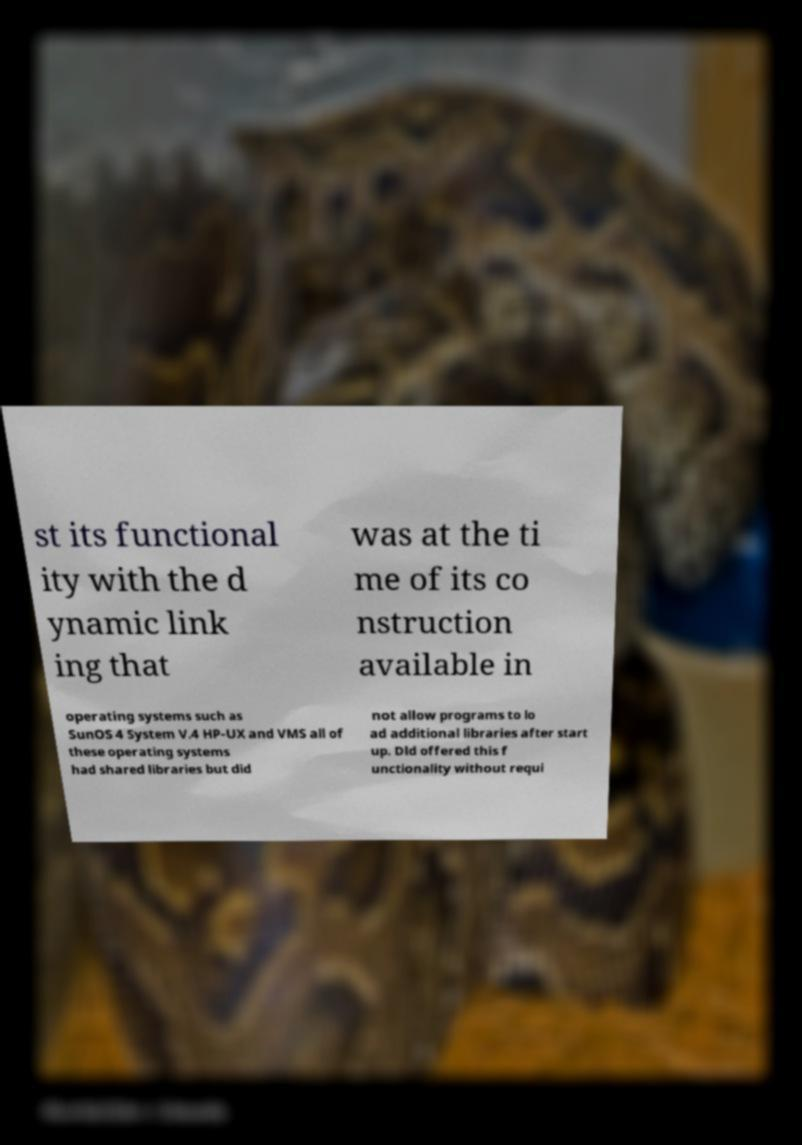Please identify and transcribe the text found in this image. st its functional ity with the d ynamic link ing that was at the ti me of its co nstruction available in operating systems such as SunOS 4 System V.4 HP-UX and VMS all of these operating systems had shared libraries but did not allow programs to lo ad additional libraries after start up. Dld offered this f unctionality without requi 